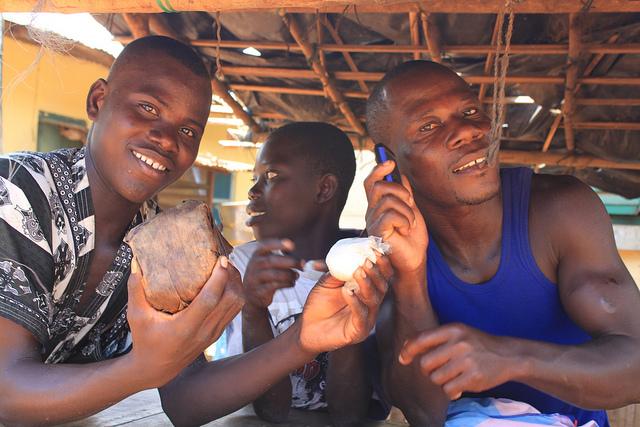Are the people in the picture males or females?
Be succinct. Males. How many people are in this photo?
Keep it brief. 3. Is this in America?
Write a very short answer. No. 